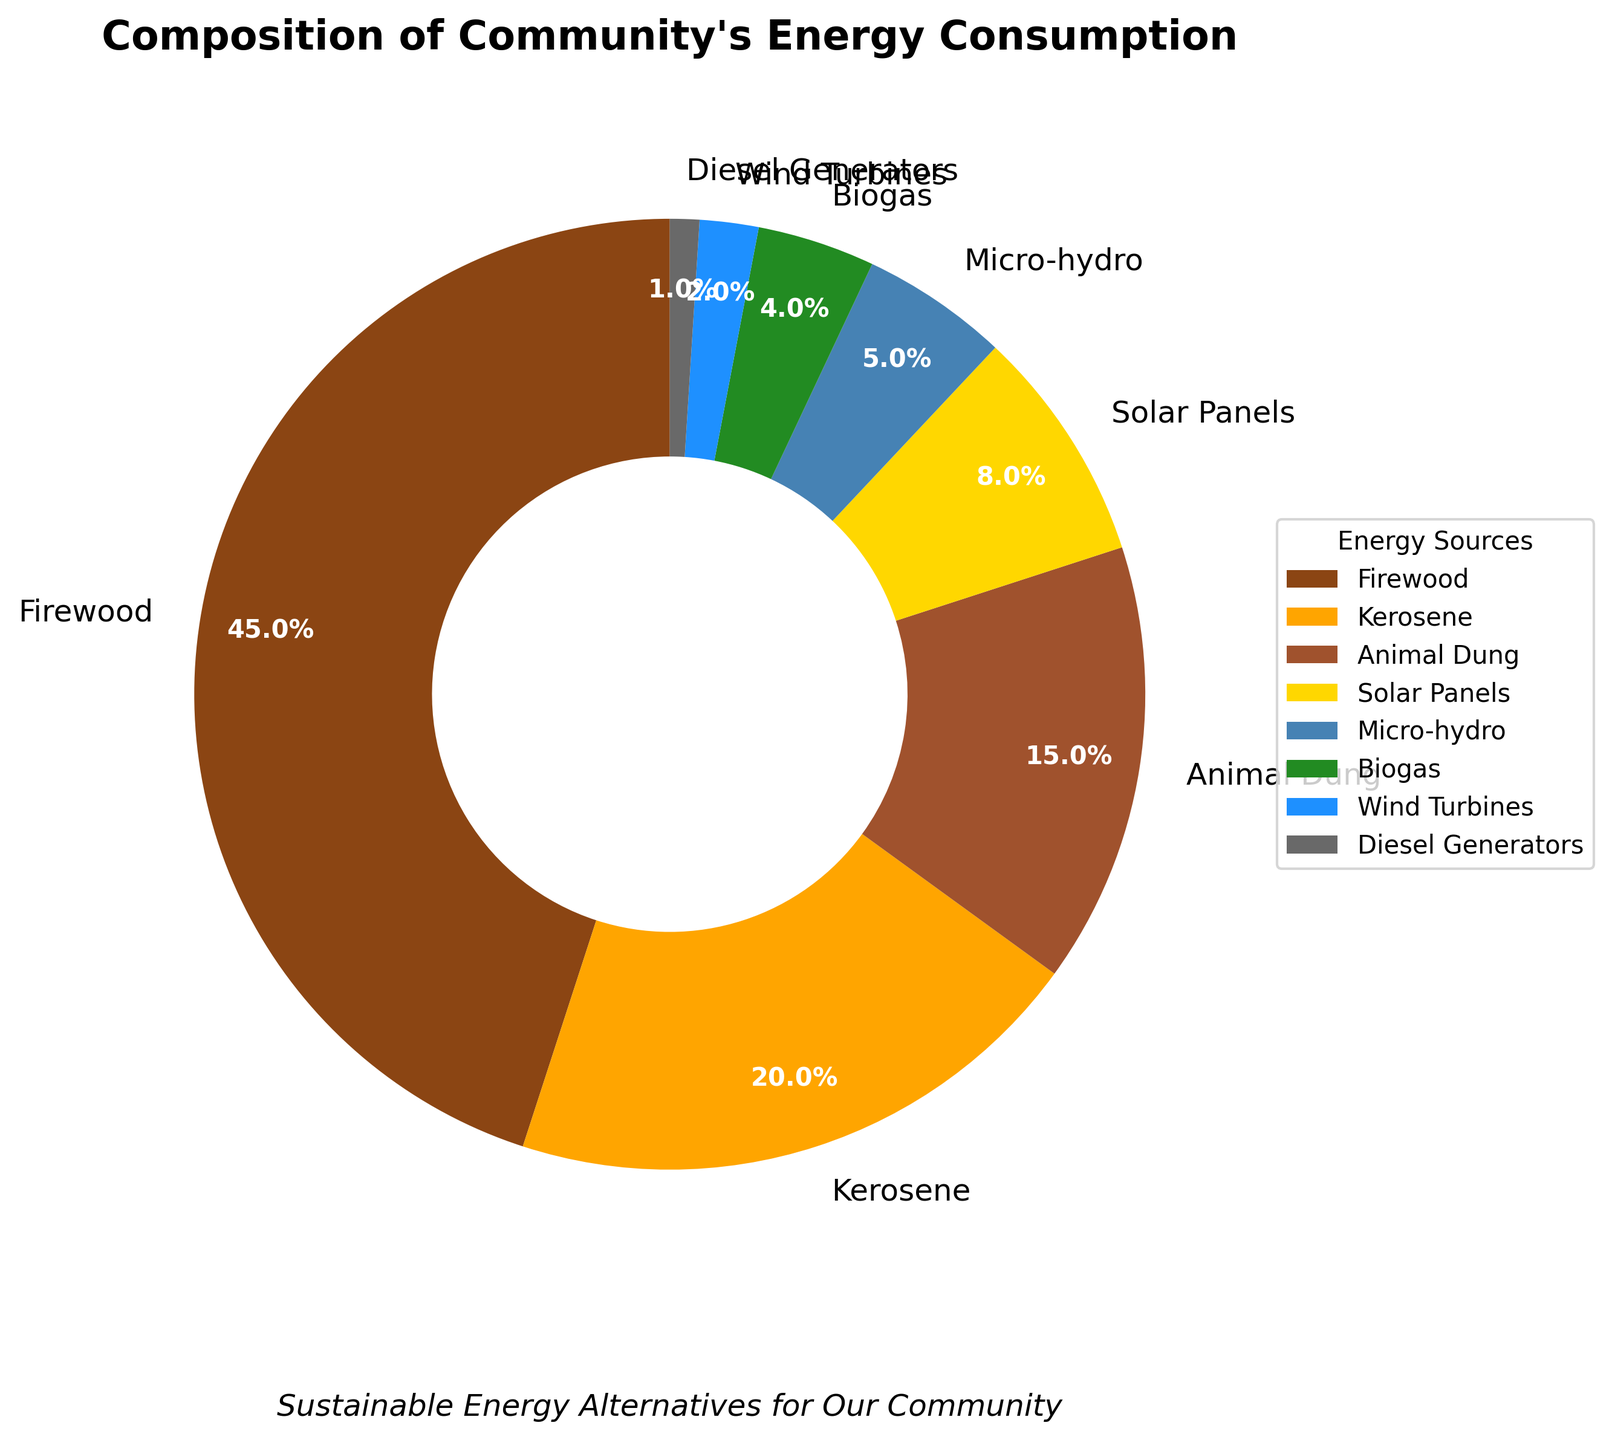What percentage of the community's energy consumption comes from renewable sources? To answer this, we need to sum the percentages for Solar Panels, Micro-hydro, Biogas, and Wind Turbines. Adding 8% (Solar Panels) + 5% (Micro-hydro) + 4% (Biogas) + 2% (Wind Turbines) gives a total of 19%.
Answer: 19% Which energy source has the highest percentage of consumption? By examining the pie chart, Firewood has the largest slice in the chart with a percentage of 45%, making it the highest energy source.
Answer: Firewood What is the difference in percentage between Firewood and Kerosene consumption? Firewood consumption is 45% and Kerosene consumption is 20%. The difference is calculated by subtracting 20% from 45%, resulting in 25%.
Answer: 25% Which energy sources have a percentage less than 10%? By looking at the chart, the energy sources with less than 10% consumption are Solar Panels (8%), Micro-hydro (5%), Biogas (4%), Wind Turbines (2%), and Diesel Generators (1%).
Answer: Solar Panels, Micro-hydro, Biogas, Wind Turbines, Diesel Generators Is the community's dependency on Kerosene greater than on Animal Dung? The chart shows that Kerosene consumption is 20%, while Animal Dung is 15%. Since 20% is greater than 15%, the community's dependency on Kerosene is indeed greater than on Animal Dung.
Answer: Yes What portion of the pie chart is dedicated to alternative renewable energy sources (Solar Panels, Micro-hydro, Biogas, and Wind Turbines) visually compared to traditional sources like Firewood and Kerosene? Visually, the pie chart shows that renewable sources (Solar Panels, Micro-hydro, Biogas, Wind Turbines) form a significantly smaller combined portion than the slices for Firewood and Kerosene. The renewable chunk is noticeably less than the slice for Firewood alone.
Answer: Smaller If the total percentage for Firewood and Kerosene were combined, would it be more than 50% of the entire pie chart? Combining Firewood (45%) and Kerosene (20%) results in 65%. Since 65% is more than half of the pie chart, it exceeds 50%.
Answer: Yes, 65% What energy source is represented by the smallest section of the pie chart? By observing the smallest section in the pie chart, Diesel Generators represent the smallest portion with just 1%.
Answer: Diesel Generators How much more is the community reliant on Firewood compared to Solar Panels and Micro-hydro combined? The pie chart shows Firewood at 45%. Solar Panels and Micro-hydro together add up to 8% + 5% = 13%. Subtracting 13% from 45% results in 32%, showing how much more Firewood is relied upon.
Answer: 32% Which section, the Firewood or the sum of all renewable sources, is larger visually? Firewood (45%) is a single large segment, while the sum of all renewable sources (19%) is a composite of smaller segments. Visually, Firewood is larger.
Answer: Firewood 